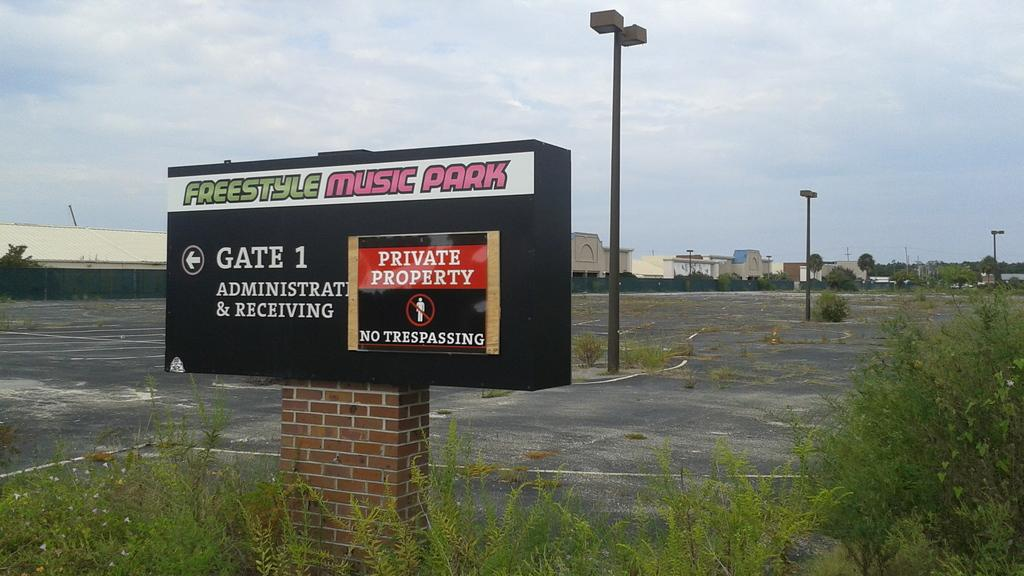<image>
Create a compact narrative representing the image presented. the sign for the music park states that it is private property 